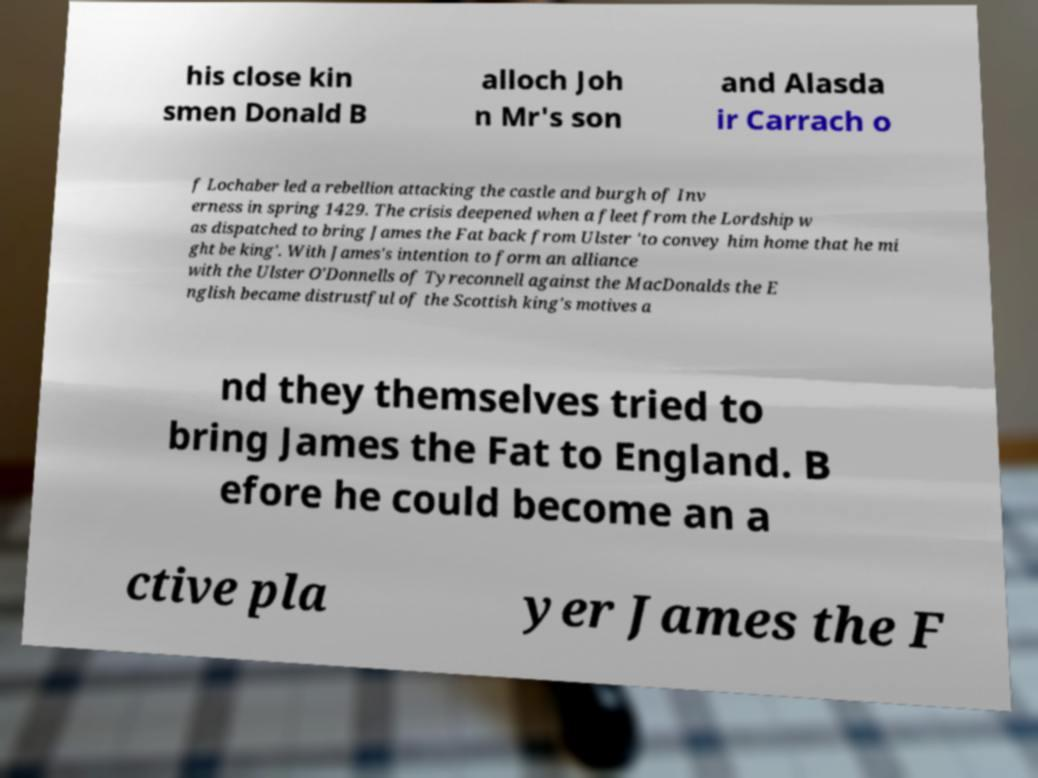I need the written content from this picture converted into text. Can you do that? his close kin smen Donald B alloch Joh n Mr's son and Alasda ir Carrach o f Lochaber led a rebellion attacking the castle and burgh of Inv erness in spring 1429. The crisis deepened when a fleet from the Lordship w as dispatched to bring James the Fat back from Ulster 'to convey him home that he mi ght be king'. With James's intention to form an alliance with the Ulster O'Donnells of Tyreconnell against the MacDonalds the E nglish became distrustful of the Scottish king's motives a nd they themselves tried to bring James the Fat to England. B efore he could become an a ctive pla yer James the F 